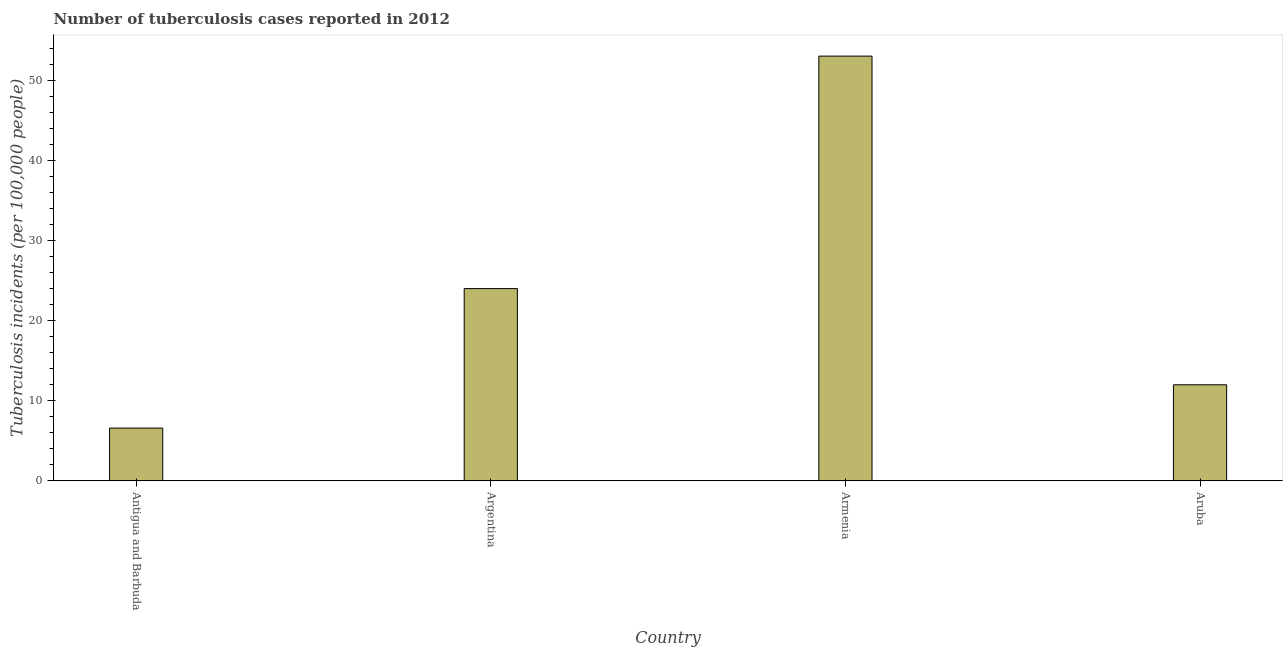Does the graph contain grids?
Provide a succinct answer. No. What is the title of the graph?
Your answer should be compact. Number of tuberculosis cases reported in 2012. What is the label or title of the X-axis?
Make the answer very short. Country. What is the label or title of the Y-axis?
Offer a very short reply. Tuberculosis incidents (per 100,0 people). What is the number of tuberculosis incidents in Argentina?
Your answer should be very brief. 24. Across all countries, what is the maximum number of tuberculosis incidents?
Keep it short and to the point. 53. Across all countries, what is the minimum number of tuberculosis incidents?
Provide a succinct answer. 6.6. In which country was the number of tuberculosis incidents maximum?
Keep it short and to the point. Armenia. In which country was the number of tuberculosis incidents minimum?
Ensure brevity in your answer.  Antigua and Barbuda. What is the sum of the number of tuberculosis incidents?
Keep it short and to the point. 95.6. What is the difference between the number of tuberculosis incidents in Antigua and Barbuda and Armenia?
Offer a terse response. -46.4. What is the average number of tuberculosis incidents per country?
Your answer should be compact. 23.9. What is the median number of tuberculosis incidents?
Provide a succinct answer. 18. Is the number of tuberculosis incidents in Antigua and Barbuda less than that in Argentina?
Provide a succinct answer. Yes. Is the difference between the number of tuberculosis incidents in Armenia and Aruba greater than the difference between any two countries?
Your response must be concise. No. What is the difference between the highest and the second highest number of tuberculosis incidents?
Your answer should be compact. 29. What is the difference between the highest and the lowest number of tuberculosis incidents?
Keep it short and to the point. 46.4. How many bars are there?
Make the answer very short. 4. Are all the bars in the graph horizontal?
Your answer should be compact. No. How many countries are there in the graph?
Provide a succinct answer. 4. What is the difference between two consecutive major ticks on the Y-axis?
Give a very brief answer. 10. What is the Tuberculosis incidents (per 100,000 people) in Argentina?
Provide a succinct answer. 24. What is the difference between the Tuberculosis incidents (per 100,000 people) in Antigua and Barbuda and Argentina?
Make the answer very short. -17.4. What is the difference between the Tuberculosis incidents (per 100,000 people) in Antigua and Barbuda and Armenia?
Give a very brief answer. -46.4. What is the difference between the Tuberculosis incidents (per 100,000 people) in Argentina and Armenia?
Provide a succinct answer. -29. What is the ratio of the Tuberculosis incidents (per 100,000 people) in Antigua and Barbuda to that in Argentina?
Give a very brief answer. 0.28. What is the ratio of the Tuberculosis incidents (per 100,000 people) in Antigua and Barbuda to that in Aruba?
Provide a succinct answer. 0.55. What is the ratio of the Tuberculosis incidents (per 100,000 people) in Argentina to that in Armenia?
Your answer should be very brief. 0.45. What is the ratio of the Tuberculosis incidents (per 100,000 people) in Armenia to that in Aruba?
Offer a terse response. 4.42. 